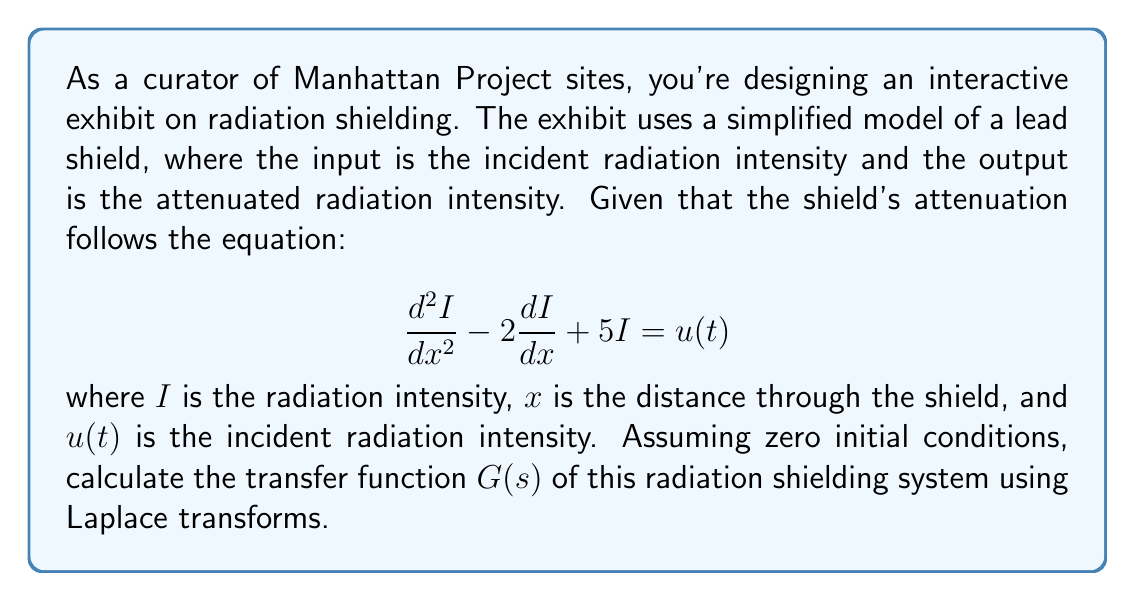Solve this math problem. To solve this problem, we'll use the following steps:

1) First, we need to take the Laplace transform of the given differential equation. Let $\mathcal{L}\{I(x)\} = Y(s)$ and $\mathcal{L}\{u(t)\} = U(s)$. The Laplace transform of the equation is:

   $$s^2Y(s) - 2sY(s) + 5Y(s) = U(s)$$

2) Factoring out $Y(s)$:

   $$(s^2 - 2s + 5)Y(s) = U(s)$$

3) The transfer function $G(s)$ is defined as the ratio of the output $Y(s)$ to the input $U(s)$:

   $$G(s) = \frac{Y(s)}{U(s)} = \frac{1}{s^2 - 2s + 5}$$

4) We can factor the denominator to get the standard form:

   $$s^2 - 2s + 5 = (s-1)^2 + 4$$

5) Therefore, the transfer function can be written as:

   $$G(s) = \frac{1}{(s-1)^2 + 4}$$

This transfer function represents how the radiation shielding system responds to incident radiation in the Laplace domain.
Answer: $$G(s) = \frac{1}{(s-1)^2 + 4}$$ 